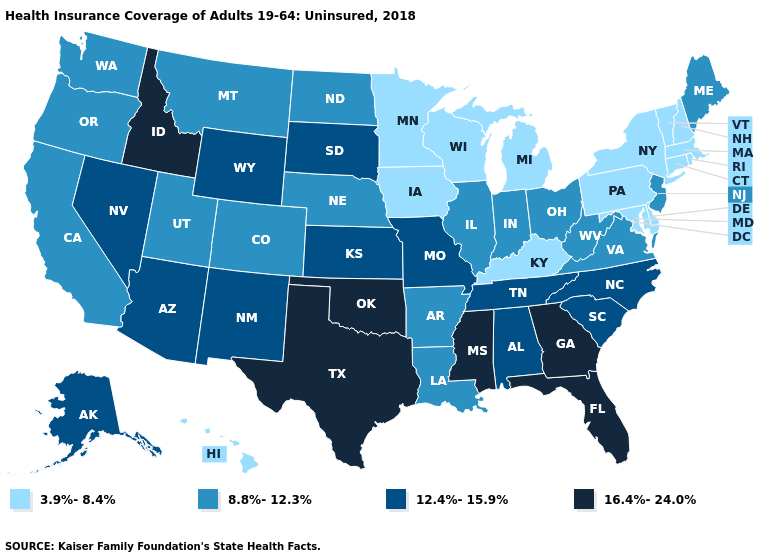Name the states that have a value in the range 3.9%-8.4%?
Be succinct. Connecticut, Delaware, Hawaii, Iowa, Kentucky, Maryland, Massachusetts, Michigan, Minnesota, New Hampshire, New York, Pennsylvania, Rhode Island, Vermont, Wisconsin. What is the highest value in states that border Tennessee?
Write a very short answer. 16.4%-24.0%. Name the states that have a value in the range 8.8%-12.3%?
Be succinct. Arkansas, California, Colorado, Illinois, Indiana, Louisiana, Maine, Montana, Nebraska, New Jersey, North Dakota, Ohio, Oregon, Utah, Virginia, Washington, West Virginia. What is the value of Texas?
Short answer required. 16.4%-24.0%. Does Oregon have the lowest value in the USA?
Keep it brief. No. What is the highest value in the MidWest ?
Give a very brief answer. 12.4%-15.9%. Name the states that have a value in the range 12.4%-15.9%?
Short answer required. Alabama, Alaska, Arizona, Kansas, Missouri, Nevada, New Mexico, North Carolina, South Carolina, South Dakota, Tennessee, Wyoming. Name the states that have a value in the range 12.4%-15.9%?
Write a very short answer. Alabama, Alaska, Arizona, Kansas, Missouri, Nevada, New Mexico, North Carolina, South Carolina, South Dakota, Tennessee, Wyoming. Does Minnesota have a higher value than Hawaii?
Write a very short answer. No. Among the states that border Colorado , does Nebraska have the lowest value?
Short answer required. Yes. What is the value of Utah?
Short answer required. 8.8%-12.3%. What is the highest value in the USA?
Give a very brief answer. 16.4%-24.0%. Does Maine have the same value as California?
Write a very short answer. Yes. Does Maryland have the highest value in the South?
Give a very brief answer. No. What is the value of Washington?
Write a very short answer. 8.8%-12.3%. 